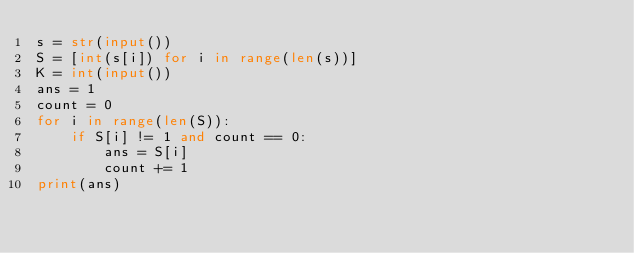<code> <loc_0><loc_0><loc_500><loc_500><_Python_>s = str(input())
S = [int(s[i]) for i in range(len(s))]
K = int(input())
ans = 1
count = 0
for i in range(len(S)):
    if S[i] != 1 and count == 0:
        ans = S[i]
        count += 1
print(ans)</code> 